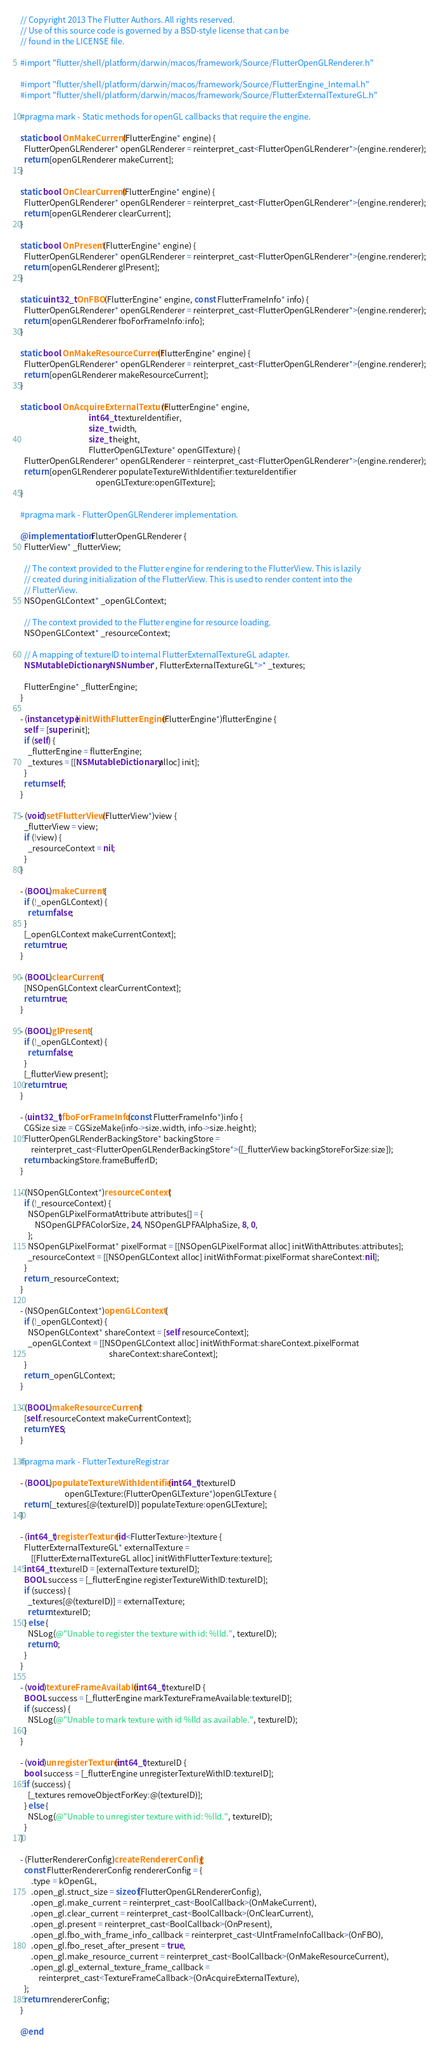Convert code to text. <code><loc_0><loc_0><loc_500><loc_500><_ObjectiveC_>// Copyright 2013 The Flutter Authors. All rights reserved.
// Use of this source code is governed by a BSD-style license that can be
// found in the LICENSE file.

#import "flutter/shell/platform/darwin/macos/framework/Source/FlutterOpenGLRenderer.h"

#import "flutter/shell/platform/darwin/macos/framework/Source/FlutterEngine_Internal.h"
#import "flutter/shell/platform/darwin/macos/framework/Source/FlutterExternalTextureGL.h"

#pragma mark - Static methods for openGL callbacks that require the engine.

static bool OnMakeCurrent(FlutterEngine* engine) {
  FlutterOpenGLRenderer* openGLRenderer = reinterpret_cast<FlutterOpenGLRenderer*>(engine.renderer);
  return [openGLRenderer makeCurrent];
}

static bool OnClearCurrent(FlutterEngine* engine) {
  FlutterOpenGLRenderer* openGLRenderer = reinterpret_cast<FlutterOpenGLRenderer*>(engine.renderer);
  return [openGLRenderer clearCurrent];
}

static bool OnPresent(FlutterEngine* engine) {
  FlutterOpenGLRenderer* openGLRenderer = reinterpret_cast<FlutterOpenGLRenderer*>(engine.renderer);
  return [openGLRenderer glPresent];
}

static uint32_t OnFBO(FlutterEngine* engine, const FlutterFrameInfo* info) {
  FlutterOpenGLRenderer* openGLRenderer = reinterpret_cast<FlutterOpenGLRenderer*>(engine.renderer);
  return [openGLRenderer fboForFrameInfo:info];
}

static bool OnMakeResourceCurrent(FlutterEngine* engine) {
  FlutterOpenGLRenderer* openGLRenderer = reinterpret_cast<FlutterOpenGLRenderer*>(engine.renderer);
  return [openGLRenderer makeResourceCurrent];
}

static bool OnAcquireExternalTexture(FlutterEngine* engine,
                                     int64_t textureIdentifier,
                                     size_t width,
                                     size_t height,
                                     FlutterOpenGLTexture* openGlTexture) {
  FlutterOpenGLRenderer* openGLRenderer = reinterpret_cast<FlutterOpenGLRenderer*>(engine.renderer);
  return [openGLRenderer populateTextureWithIdentifier:textureIdentifier
                                         openGLTexture:openGlTexture];
}

#pragma mark - FlutterOpenGLRenderer implementation.

@implementation FlutterOpenGLRenderer {
  FlutterView* _flutterView;

  // The context provided to the Flutter engine for rendering to the FlutterView. This is lazily
  // created during initialization of the FlutterView. This is used to render content into the
  // FlutterView.
  NSOpenGLContext* _openGLContext;

  // The context provided to the Flutter engine for resource loading.
  NSOpenGLContext* _resourceContext;

  // A mapping of textureID to internal FlutterExternalTextureGL adapter.
  NSMutableDictionary<NSNumber*, FlutterExternalTextureGL*>* _textures;

  FlutterEngine* _flutterEngine;
}

- (instancetype)initWithFlutterEngine:(FlutterEngine*)flutterEngine {
  self = [super init];
  if (self) {
    _flutterEngine = flutterEngine;
    _textures = [[NSMutableDictionary alloc] init];
  }
  return self;
}

- (void)setFlutterView:(FlutterView*)view {
  _flutterView = view;
  if (!view) {
    _resourceContext = nil;
  }
}

- (BOOL)makeCurrent {
  if (!_openGLContext) {
    return false;
  }
  [_openGLContext makeCurrentContext];
  return true;
}

- (BOOL)clearCurrent {
  [NSOpenGLContext clearCurrentContext];
  return true;
}

- (BOOL)glPresent {
  if (!_openGLContext) {
    return false;
  }
  [_flutterView present];
  return true;
}

- (uint32_t)fboForFrameInfo:(const FlutterFrameInfo*)info {
  CGSize size = CGSizeMake(info->size.width, info->size.height);
  FlutterOpenGLRenderBackingStore* backingStore =
      reinterpret_cast<FlutterOpenGLRenderBackingStore*>([_flutterView backingStoreForSize:size]);
  return backingStore.frameBufferID;
}

- (NSOpenGLContext*)resourceContext {
  if (!_resourceContext) {
    NSOpenGLPixelFormatAttribute attributes[] = {
        NSOpenGLPFAColorSize, 24, NSOpenGLPFAAlphaSize, 8, 0,
    };
    NSOpenGLPixelFormat* pixelFormat = [[NSOpenGLPixelFormat alloc] initWithAttributes:attributes];
    _resourceContext = [[NSOpenGLContext alloc] initWithFormat:pixelFormat shareContext:nil];
  }
  return _resourceContext;
}

- (NSOpenGLContext*)openGLContext {
  if (!_openGLContext) {
    NSOpenGLContext* shareContext = [self resourceContext];
    _openGLContext = [[NSOpenGLContext alloc] initWithFormat:shareContext.pixelFormat
                                                shareContext:shareContext];
  }
  return _openGLContext;
}

- (BOOL)makeResourceCurrent {
  [self.resourceContext makeCurrentContext];
  return YES;
}

#pragma mark - FlutterTextureRegistrar

- (BOOL)populateTextureWithIdentifier:(int64_t)textureID
                        openGLTexture:(FlutterOpenGLTexture*)openGLTexture {
  return [_textures[@(textureID)] populateTexture:openGLTexture];
}

- (int64_t)registerTexture:(id<FlutterTexture>)texture {
  FlutterExternalTextureGL* externalTexture =
      [[FlutterExternalTextureGL alloc] initWithFlutterTexture:texture];
  int64_t textureID = [externalTexture textureID];
  BOOL success = [_flutterEngine registerTextureWithID:textureID];
  if (success) {
    _textures[@(textureID)] = externalTexture;
    return textureID;
  } else {
    NSLog(@"Unable to register the texture with id: %lld.", textureID);
    return 0;
  }
}

- (void)textureFrameAvailable:(int64_t)textureID {
  BOOL success = [_flutterEngine markTextureFrameAvailable:textureID];
  if (success) {
    NSLog(@"Unable to mark texture with id %lld as available.", textureID);
  }
}

- (void)unregisterTexture:(int64_t)textureID {
  bool success = [_flutterEngine unregisterTextureWithID:textureID];
  if (success) {
    [_textures removeObjectForKey:@(textureID)];
  } else {
    NSLog(@"Unable to unregister texture with id: %lld.", textureID);
  }
}

- (FlutterRendererConfig)createRendererConfig {
  const FlutterRendererConfig rendererConfig = {
      .type = kOpenGL,
      .open_gl.struct_size = sizeof(FlutterOpenGLRendererConfig),
      .open_gl.make_current = reinterpret_cast<BoolCallback>(OnMakeCurrent),
      .open_gl.clear_current = reinterpret_cast<BoolCallback>(OnClearCurrent),
      .open_gl.present = reinterpret_cast<BoolCallback>(OnPresent),
      .open_gl.fbo_with_frame_info_callback = reinterpret_cast<UIntFrameInfoCallback>(OnFBO),
      .open_gl.fbo_reset_after_present = true,
      .open_gl.make_resource_current = reinterpret_cast<BoolCallback>(OnMakeResourceCurrent),
      .open_gl.gl_external_texture_frame_callback =
          reinterpret_cast<TextureFrameCallback>(OnAcquireExternalTexture),
  };
  return rendererConfig;
}

@end
</code> 